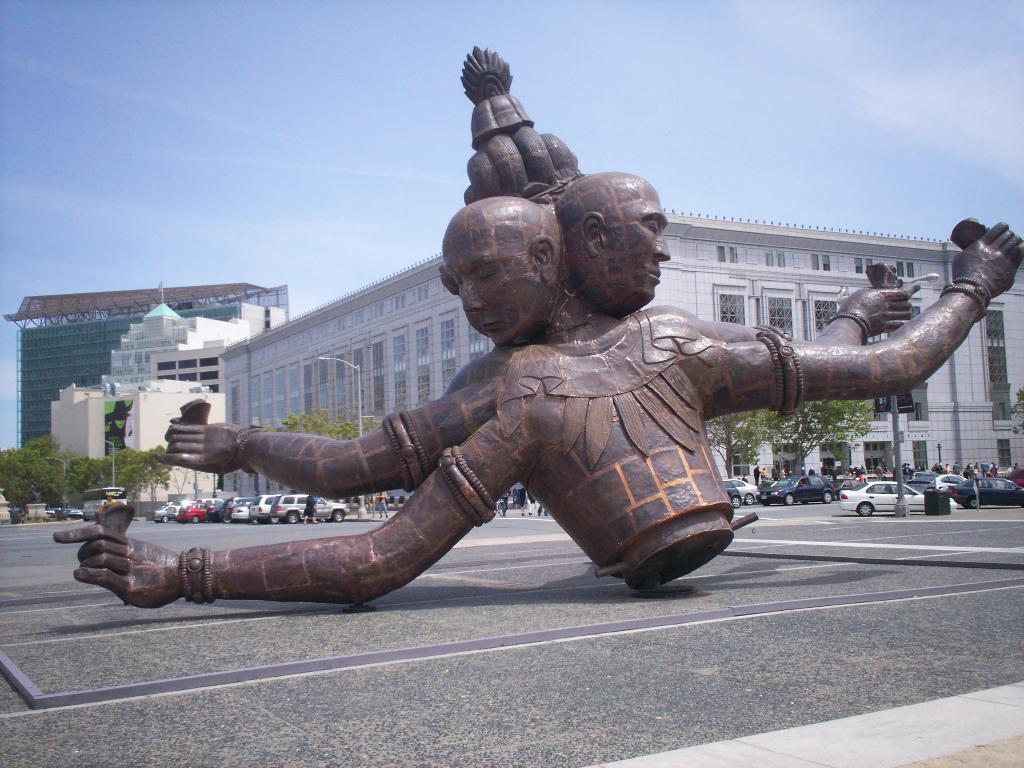What is the main subject of the image? There is a sculpture in the image. What type of natural elements can be seen in the image? There are trees in the image. What type of man-made structures are present in the image? There are buildings in the image. What type of street infrastructure is visible in the image? There are light poles in the image. What type of transportation is present in the image? There are vehicles in the image. What type of surface can be seen in the image? A: There is a road in the image. What part of the natural environment is visible in the image? The sky is visible in the image. What type of army is marching down the road in the image? There is no army present in the image; it features a sculpture, trees, buildings, light poles, vehicles, a road, and the sky. 